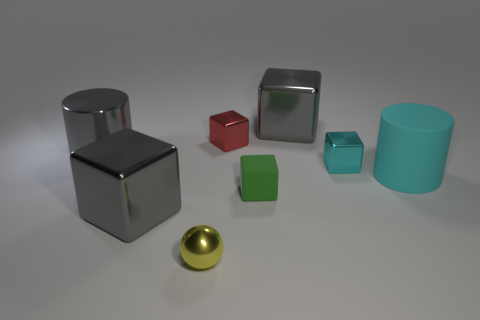The rubber object that is on the right side of the big thing behind the tiny red object is what shape?
Your answer should be compact. Cylinder. Is there a yellow metallic object that has the same shape as the tiny red thing?
Offer a very short reply. No. What number of gray things are there?
Ensure brevity in your answer.  3. Is the material of the cylinder that is on the left side of the metallic sphere the same as the yellow ball?
Your answer should be very brief. Yes. Are there any green matte things that have the same size as the cyan cube?
Your answer should be compact. Yes. There is a tiny matte object; does it have the same shape as the cyan thing that is in front of the tiny cyan metallic thing?
Your response must be concise. No. There is a large cube that is behind the cylinder to the right of the small metallic ball; are there any rubber cylinders that are right of it?
Your answer should be very brief. Yes. What size is the gray cylinder?
Your response must be concise. Large. How many other objects are the same color as the sphere?
Your answer should be compact. 0. Do the red metallic thing right of the big shiny cylinder and the cyan metallic thing have the same shape?
Give a very brief answer. Yes. 